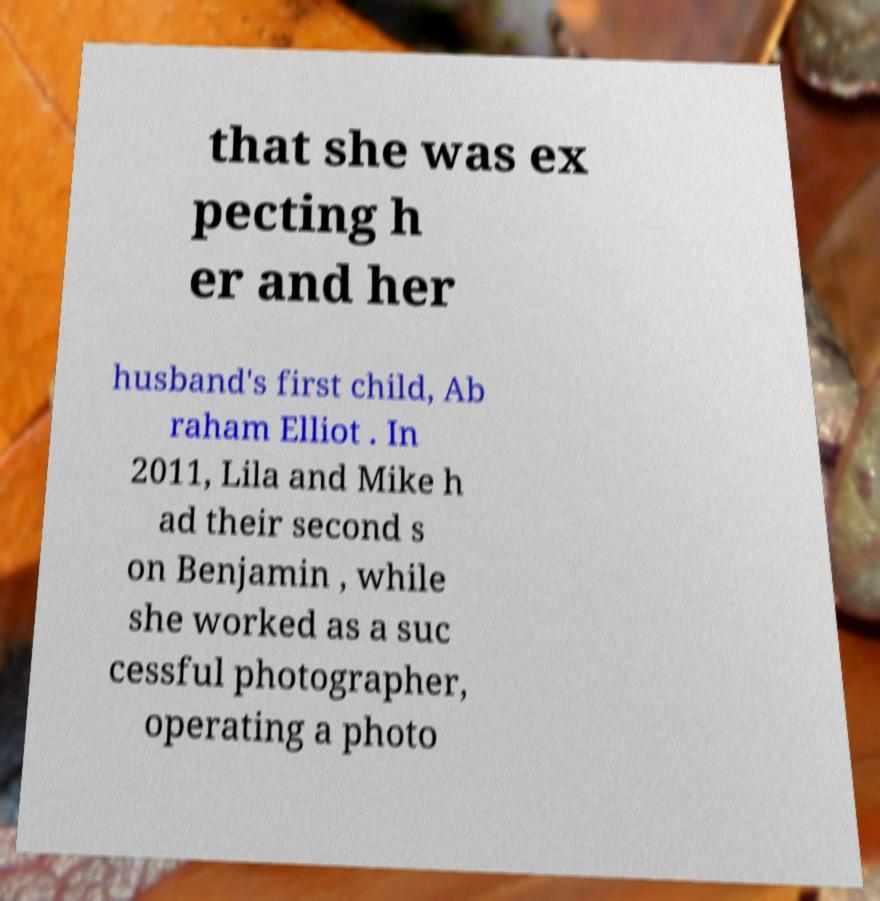There's text embedded in this image that I need extracted. Can you transcribe it verbatim? that she was ex pecting h er and her husband's first child, Ab raham Elliot . In 2011, Lila and Mike h ad their second s on Benjamin , while she worked as a suc cessful photographer, operating a photo 